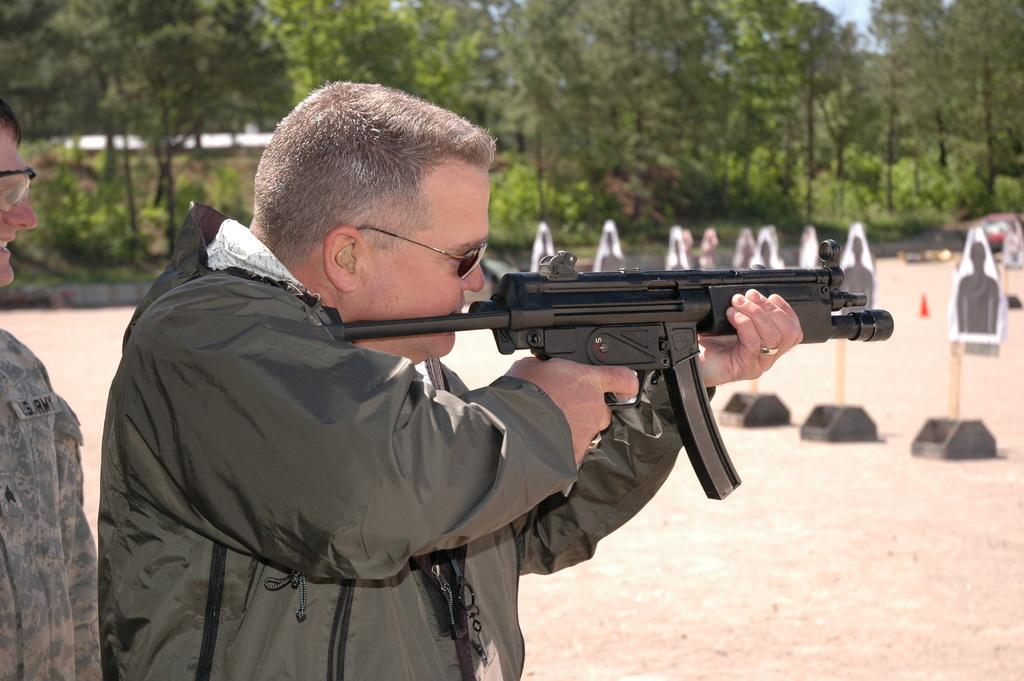How would you summarize this image in a sentence or two? In this image there is a man wearing glasses and holding gun. There is also another man with glasses. Image also consists of persons board attached to the wooden pole and is placed on the land. In the background there are many trees. 